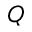Convert formula to latex. <formula><loc_0><loc_0><loc_500><loc_500>Q</formula> 